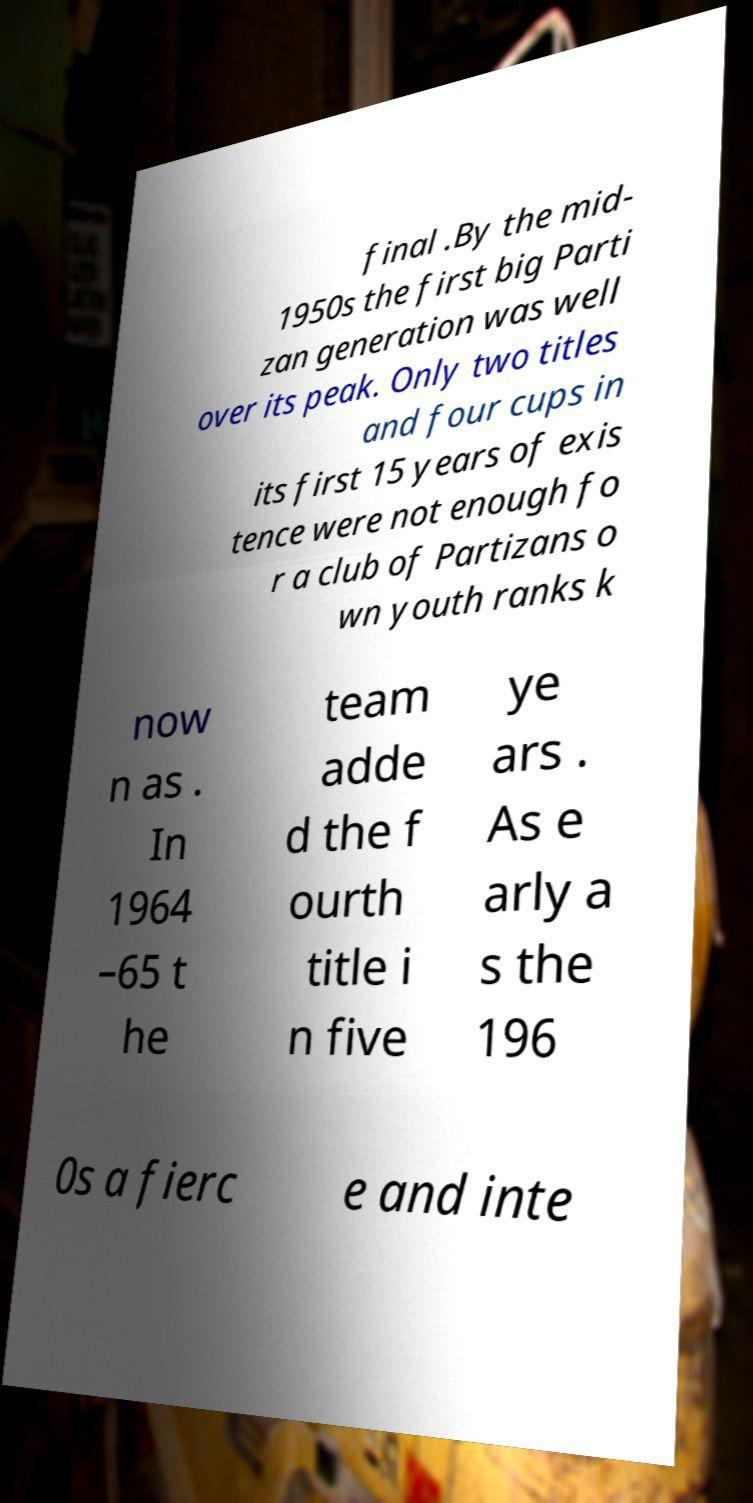For documentation purposes, I need the text within this image transcribed. Could you provide that? final .By the mid- 1950s the first big Parti zan generation was well over its peak. Only two titles and four cups in its first 15 years of exis tence were not enough fo r a club of Partizans o wn youth ranks k now n as . In 1964 –65 t he team adde d the f ourth title i n five ye ars . As e arly a s the 196 0s a fierc e and inte 